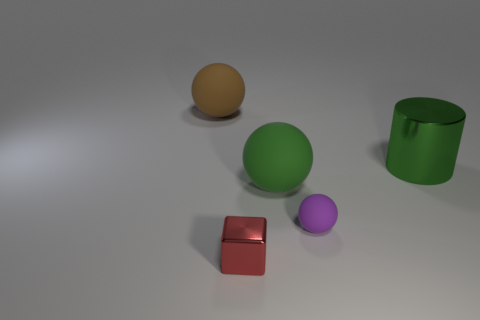Add 4 tiny blue things. How many objects exist? 9 Subtract all cylinders. How many objects are left? 4 Subtract all green objects. Subtract all brown spheres. How many objects are left? 2 Add 1 brown matte balls. How many brown matte balls are left? 2 Add 5 big brown cylinders. How many big brown cylinders exist? 5 Subtract 1 green cylinders. How many objects are left? 4 